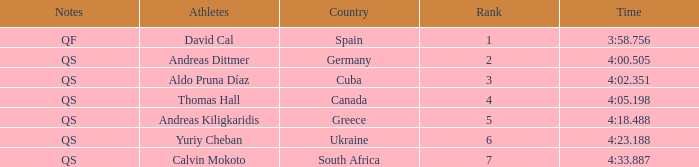What are the notes for the athlete from Spain? QF. 